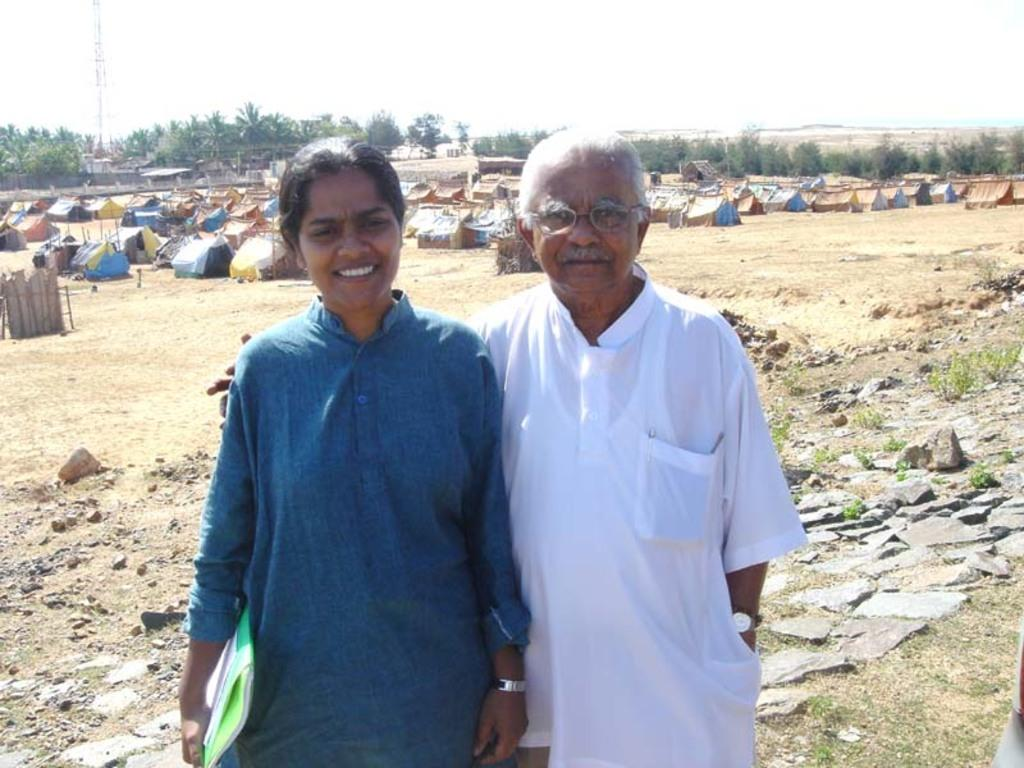Who are the people in the image? There is a man and a woman standing in the image. What type of structures can be seen in the image? There are huts and a tower in the image. What type of vegetation is present in the image? There are trees in the image. What can be seen in the background of the image? The sky is visible in the background of the image. What type of wine is being served at the gathering in the image? There is no gathering or wine present in the image. How does the tower provide support to the huts in the image? The image does not show any interaction between the tower and the huts, nor does it suggest that the tower provides support to the huts. 